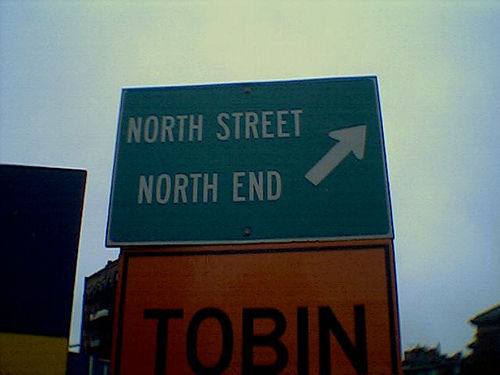Extract all visible text content from this image. NORTH STREET NORTH END TOBIN 